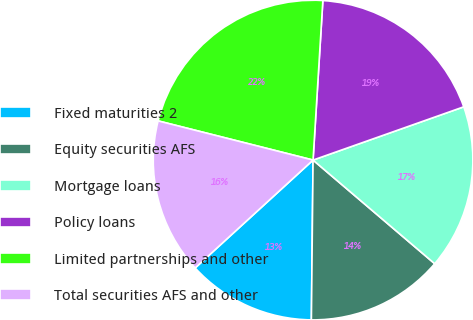Convert chart to OTSL. <chart><loc_0><loc_0><loc_500><loc_500><pie_chart><fcel>Fixed maturities 2<fcel>Equity securities AFS<fcel>Mortgage loans<fcel>Policy loans<fcel>Limited partnerships and other<fcel>Total securities AFS and other<nl><fcel>13.04%<fcel>13.94%<fcel>16.64%<fcel>18.62%<fcel>22.04%<fcel>15.74%<nl></chart> 